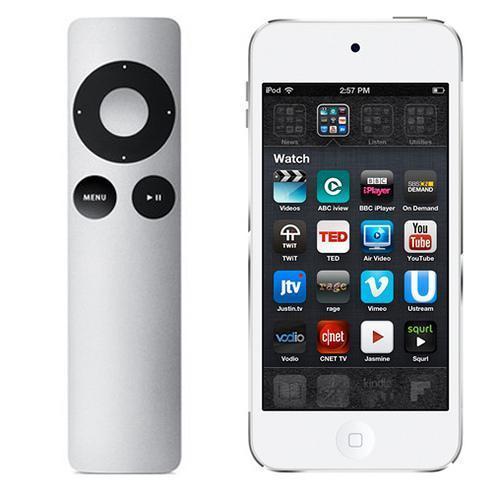How many phones are there?
Give a very brief answer. 1. 